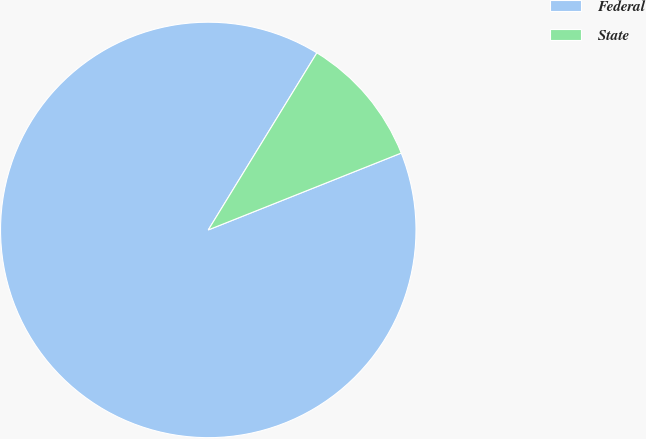Convert chart. <chart><loc_0><loc_0><loc_500><loc_500><pie_chart><fcel>Federal<fcel>State<nl><fcel>89.79%<fcel>10.21%<nl></chart> 